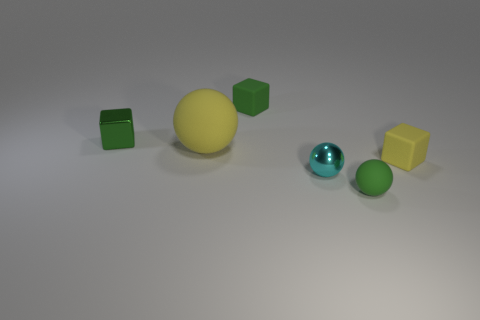Do the tiny rubber sphere and the shiny block have the same color?
Provide a short and direct response. Yes. What is the shape of the small rubber thing that is the same color as the large sphere?
Make the answer very short. Cube. What number of tiny green cylinders are made of the same material as the tiny yellow object?
Make the answer very short. 0. What is the cyan sphere made of?
Provide a short and direct response. Metal. What shape is the small green object that is in front of the large matte sphere that is behind the small green ball?
Keep it short and to the point. Sphere. There is a green rubber object behind the green rubber ball; what shape is it?
Keep it short and to the point. Cube. How many other metal cubes have the same color as the shiny cube?
Your answer should be compact. 0. What is the color of the large object?
Keep it short and to the point. Yellow. How many cyan balls are right of the green cube left of the yellow ball?
Give a very brief answer. 1. Does the cyan object have the same size as the yellow matte object left of the small cyan thing?
Your answer should be compact. No. 